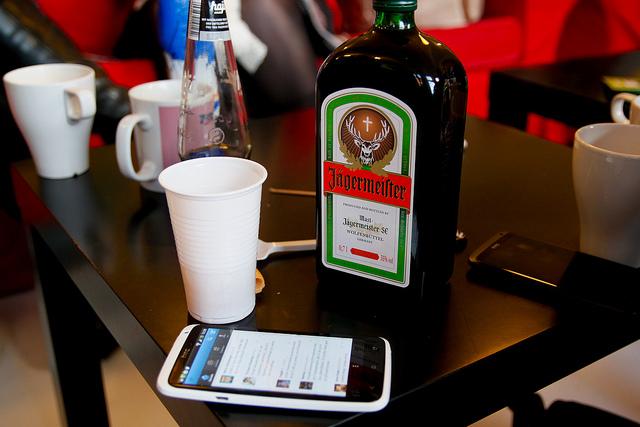What is in the bottles?
Quick response, please. Liquor. What drink is that?
Write a very short answer. Jagermeister. Is a 16-year-old legally allowed to drink the contents of the bottle?
Short answer required. No. Where was the soda in the cup purchased?
Write a very short answer. Store. Which phone is silver?
Give a very brief answer. Right. What type of liquid are they drinking?
Keep it brief. Jagermeister. What is the slim white gadget used for?
Write a very short answer. Calling people. 